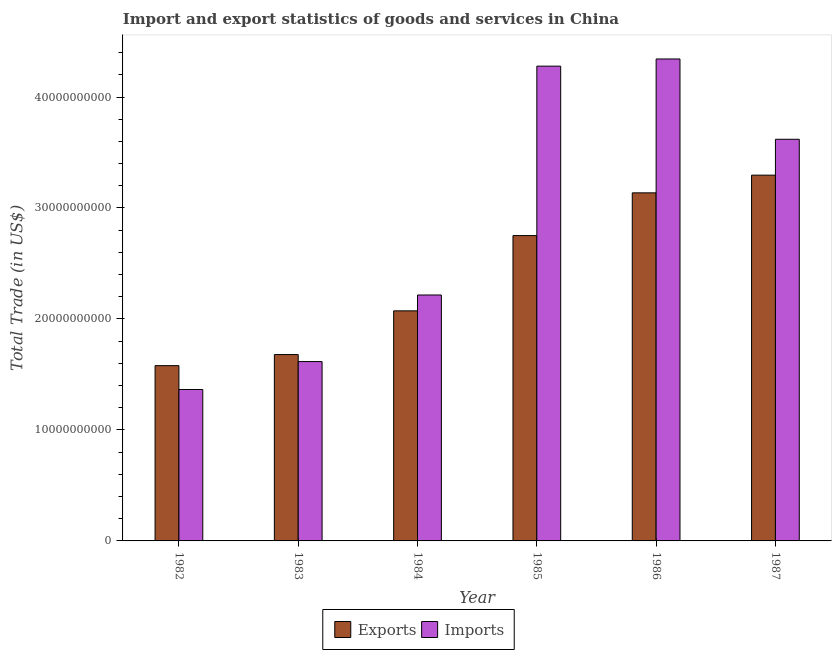What is the imports of goods and services in 1983?
Offer a terse response. 1.62e+1. Across all years, what is the maximum imports of goods and services?
Ensure brevity in your answer.  4.34e+1. Across all years, what is the minimum imports of goods and services?
Keep it short and to the point. 1.36e+1. What is the total export of goods and services in the graph?
Your answer should be compact. 1.45e+11. What is the difference between the export of goods and services in 1983 and that in 1984?
Keep it short and to the point. -3.94e+09. What is the difference between the export of goods and services in 1986 and the imports of goods and services in 1985?
Your response must be concise. 3.85e+09. What is the average export of goods and services per year?
Your response must be concise. 2.42e+1. In the year 1982, what is the difference between the export of goods and services and imports of goods and services?
Ensure brevity in your answer.  0. In how many years, is the imports of goods and services greater than 24000000000 US$?
Offer a terse response. 3. What is the ratio of the export of goods and services in 1983 to that in 1984?
Your answer should be very brief. 0.81. Is the imports of goods and services in 1983 less than that in 1984?
Your response must be concise. Yes. What is the difference between the highest and the second highest imports of goods and services?
Provide a succinct answer. 6.47e+08. What is the difference between the highest and the lowest export of goods and services?
Offer a terse response. 1.72e+1. In how many years, is the export of goods and services greater than the average export of goods and services taken over all years?
Your answer should be very brief. 3. What does the 2nd bar from the left in 1984 represents?
Your answer should be very brief. Imports. What does the 2nd bar from the right in 1983 represents?
Your answer should be compact. Exports. How many bars are there?
Provide a succinct answer. 12. Are all the bars in the graph horizontal?
Provide a short and direct response. No. Does the graph contain any zero values?
Keep it short and to the point. No. Does the graph contain grids?
Make the answer very short. No. How many legend labels are there?
Provide a succinct answer. 2. What is the title of the graph?
Provide a short and direct response. Import and export statistics of goods and services in China. Does "Nitrous oxide emissions" appear as one of the legend labels in the graph?
Your answer should be compact. No. What is the label or title of the Y-axis?
Offer a very short reply. Total Trade (in US$). What is the Total Trade (in US$) in Exports in 1982?
Your answer should be compact. 1.58e+1. What is the Total Trade (in US$) of Imports in 1982?
Ensure brevity in your answer.  1.36e+1. What is the Total Trade (in US$) of Exports in 1983?
Make the answer very short. 1.68e+1. What is the Total Trade (in US$) in Imports in 1983?
Keep it short and to the point. 1.62e+1. What is the Total Trade (in US$) in Exports in 1984?
Keep it short and to the point. 2.07e+1. What is the Total Trade (in US$) in Imports in 1984?
Ensure brevity in your answer.  2.22e+1. What is the Total Trade (in US$) in Exports in 1985?
Make the answer very short. 2.75e+1. What is the Total Trade (in US$) of Imports in 1985?
Keep it short and to the point. 4.28e+1. What is the Total Trade (in US$) in Exports in 1986?
Make the answer very short. 3.14e+1. What is the Total Trade (in US$) in Imports in 1986?
Provide a short and direct response. 4.34e+1. What is the Total Trade (in US$) of Exports in 1987?
Ensure brevity in your answer.  3.30e+1. What is the Total Trade (in US$) of Imports in 1987?
Offer a very short reply. 3.62e+1. Across all years, what is the maximum Total Trade (in US$) in Exports?
Ensure brevity in your answer.  3.30e+1. Across all years, what is the maximum Total Trade (in US$) of Imports?
Your response must be concise. 4.34e+1. Across all years, what is the minimum Total Trade (in US$) of Exports?
Ensure brevity in your answer.  1.58e+1. Across all years, what is the minimum Total Trade (in US$) in Imports?
Provide a short and direct response. 1.36e+1. What is the total Total Trade (in US$) in Exports in the graph?
Provide a succinct answer. 1.45e+11. What is the total Total Trade (in US$) in Imports in the graph?
Give a very brief answer. 1.74e+11. What is the difference between the Total Trade (in US$) in Exports in 1982 and that in 1983?
Keep it short and to the point. -9.99e+08. What is the difference between the Total Trade (in US$) of Imports in 1982 and that in 1983?
Ensure brevity in your answer.  -2.52e+09. What is the difference between the Total Trade (in US$) in Exports in 1982 and that in 1984?
Your answer should be compact. -4.94e+09. What is the difference between the Total Trade (in US$) in Imports in 1982 and that in 1984?
Your response must be concise. -8.52e+09. What is the difference between the Total Trade (in US$) in Exports in 1982 and that in 1985?
Provide a short and direct response. -1.17e+1. What is the difference between the Total Trade (in US$) of Imports in 1982 and that in 1985?
Offer a terse response. -2.91e+1. What is the difference between the Total Trade (in US$) in Exports in 1982 and that in 1986?
Provide a short and direct response. -1.56e+1. What is the difference between the Total Trade (in US$) in Imports in 1982 and that in 1986?
Offer a terse response. -2.98e+1. What is the difference between the Total Trade (in US$) in Exports in 1982 and that in 1987?
Make the answer very short. -1.72e+1. What is the difference between the Total Trade (in US$) in Imports in 1982 and that in 1987?
Provide a short and direct response. -2.25e+1. What is the difference between the Total Trade (in US$) of Exports in 1983 and that in 1984?
Make the answer very short. -3.94e+09. What is the difference between the Total Trade (in US$) in Imports in 1983 and that in 1984?
Your response must be concise. -6.00e+09. What is the difference between the Total Trade (in US$) of Exports in 1983 and that in 1985?
Offer a very short reply. -1.07e+1. What is the difference between the Total Trade (in US$) in Imports in 1983 and that in 1985?
Offer a very short reply. -2.66e+1. What is the difference between the Total Trade (in US$) of Exports in 1983 and that in 1986?
Your answer should be very brief. -1.46e+1. What is the difference between the Total Trade (in US$) in Imports in 1983 and that in 1986?
Ensure brevity in your answer.  -2.73e+1. What is the difference between the Total Trade (in US$) of Exports in 1983 and that in 1987?
Offer a terse response. -1.62e+1. What is the difference between the Total Trade (in US$) of Imports in 1983 and that in 1987?
Provide a short and direct response. -2.00e+1. What is the difference between the Total Trade (in US$) of Exports in 1984 and that in 1985?
Make the answer very short. -6.78e+09. What is the difference between the Total Trade (in US$) of Imports in 1984 and that in 1985?
Give a very brief answer. -2.06e+1. What is the difference between the Total Trade (in US$) in Exports in 1984 and that in 1986?
Offer a very short reply. -1.06e+1. What is the difference between the Total Trade (in US$) in Imports in 1984 and that in 1986?
Your answer should be compact. -2.13e+1. What is the difference between the Total Trade (in US$) of Exports in 1984 and that in 1987?
Your answer should be compact. -1.22e+1. What is the difference between the Total Trade (in US$) of Imports in 1984 and that in 1987?
Provide a succinct answer. -1.40e+1. What is the difference between the Total Trade (in US$) in Exports in 1985 and that in 1986?
Keep it short and to the point. -3.85e+09. What is the difference between the Total Trade (in US$) of Imports in 1985 and that in 1986?
Provide a short and direct response. -6.47e+08. What is the difference between the Total Trade (in US$) in Exports in 1985 and that in 1987?
Provide a succinct answer. -5.45e+09. What is the difference between the Total Trade (in US$) of Imports in 1985 and that in 1987?
Provide a succinct answer. 6.59e+09. What is the difference between the Total Trade (in US$) of Exports in 1986 and that in 1987?
Your response must be concise. -1.59e+09. What is the difference between the Total Trade (in US$) of Imports in 1986 and that in 1987?
Provide a succinct answer. 7.24e+09. What is the difference between the Total Trade (in US$) of Exports in 1982 and the Total Trade (in US$) of Imports in 1983?
Your response must be concise. -3.67e+08. What is the difference between the Total Trade (in US$) of Exports in 1982 and the Total Trade (in US$) of Imports in 1984?
Keep it short and to the point. -6.37e+09. What is the difference between the Total Trade (in US$) in Exports in 1982 and the Total Trade (in US$) in Imports in 1985?
Provide a succinct answer. -2.70e+1. What is the difference between the Total Trade (in US$) in Exports in 1982 and the Total Trade (in US$) in Imports in 1986?
Offer a terse response. -2.76e+1. What is the difference between the Total Trade (in US$) in Exports in 1982 and the Total Trade (in US$) in Imports in 1987?
Offer a very short reply. -2.04e+1. What is the difference between the Total Trade (in US$) of Exports in 1983 and the Total Trade (in US$) of Imports in 1984?
Give a very brief answer. -5.37e+09. What is the difference between the Total Trade (in US$) of Exports in 1983 and the Total Trade (in US$) of Imports in 1985?
Provide a short and direct response. -2.60e+1. What is the difference between the Total Trade (in US$) of Exports in 1983 and the Total Trade (in US$) of Imports in 1986?
Ensure brevity in your answer.  -2.66e+1. What is the difference between the Total Trade (in US$) in Exports in 1983 and the Total Trade (in US$) in Imports in 1987?
Ensure brevity in your answer.  -1.94e+1. What is the difference between the Total Trade (in US$) of Exports in 1984 and the Total Trade (in US$) of Imports in 1985?
Offer a very short reply. -2.21e+1. What is the difference between the Total Trade (in US$) of Exports in 1984 and the Total Trade (in US$) of Imports in 1986?
Your answer should be compact. -2.27e+1. What is the difference between the Total Trade (in US$) of Exports in 1984 and the Total Trade (in US$) of Imports in 1987?
Provide a succinct answer. -1.55e+1. What is the difference between the Total Trade (in US$) of Exports in 1985 and the Total Trade (in US$) of Imports in 1986?
Your answer should be very brief. -1.59e+1. What is the difference between the Total Trade (in US$) in Exports in 1985 and the Total Trade (in US$) in Imports in 1987?
Offer a terse response. -8.68e+09. What is the difference between the Total Trade (in US$) in Exports in 1986 and the Total Trade (in US$) in Imports in 1987?
Offer a terse response. -4.83e+09. What is the average Total Trade (in US$) of Exports per year?
Make the answer very short. 2.42e+1. What is the average Total Trade (in US$) in Imports per year?
Your answer should be compact. 2.91e+1. In the year 1982, what is the difference between the Total Trade (in US$) of Exports and Total Trade (in US$) of Imports?
Give a very brief answer. 2.15e+09. In the year 1983, what is the difference between the Total Trade (in US$) in Exports and Total Trade (in US$) in Imports?
Your answer should be very brief. 6.32e+08. In the year 1984, what is the difference between the Total Trade (in US$) of Exports and Total Trade (in US$) of Imports?
Your answer should be compact. -1.43e+09. In the year 1985, what is the difference between the Total Trade (in US$) of Exports and Total Trade (in US$) of Imports?
Provide a succinct answer. -1.53e+1. In the year 1986, what is the difference between the Total Trade (in US$) in Exports and Total Trade (in US$) in Imports?
Make the answer very short. -1.21e+1. In the year 1987, what is the difference between the Total Trade (in US$) in Exports and Total Trade (in US$) in Imports?
Your answer should be compact. -3.23e+09. What is the ratio of the Total Trade (in US$) of Exports in 1982 to that in 1983?
Ensure brevity in your answer.  0.94. What is the ratio of the Total Trade (in US$) of Imports in 1982 to that in 1983?
Ensure brevity in your answer.  0.84. What is the ratio of the Total Trade (in US$) in Exports in 1982 to that in 1984?
Offer a very short reply. 0.76. What is the ratio of the Total Trade (in US$) of Imports in 1982 to that in 1984?
Make the answer very short. 0.62. What is the ratio of the Total Trade (in US$) in Exports in 1982 to that in 1985?
Keep it short and to the point. 0.57. What is the ratio of the Total Trade (in US$) in Imports in 1982 to that in 1985?
Your answer should be compact. 0.32. What is the ratio of the Total Trade (in US$) of Exports in 1982 to that in 1986?
Offer a terse response. 0.5. What is the ratio of the Total Trade (in US$) in Imports in 1982 to that in 1986?
Your answer should be compact. 0.31. What is the ratio of the Total Trade (in US$) in Exports in 1982 to that in 1987?
Offer a very short reply. 0.48. What is the ratio of the Total Trade (in US$) in Imports in 1982 to that in 1987?
Your answer should be compact. 0.38. What is the ratio of the Total Trade (in US$) in Exports in 1983 to that in 1984?
Give a very brief answer. 0.81. What is the ratio of the Total Trade (in US$) in Imports in 1983 to that in 1984?
Provide a short and direct response. 0.73. What is the ratio of the Total Trade (in US$) in Exports in 1983 to that in 1985?
Provide a short and direct response. 0.61. What is the ratio of the Total Trade (in US$) in Imports in 1983 to that in 1985?
Your answer should be compact. 0.38. What is the ratio of the Total Trade (in US$) in Exports in 1983 to that in 1986?
Ensure brevity in your answer.  0.54. What is the ratio of the Total Trade (in US$) in Imports in 1983 to that in 1986?
Offer a terse response. 0.37. What is the ratio of the Total Trade (in US$) in Exports in 1983 to that in 1987?
Offer a terse response. 0.51. What is the ratio of the Total Trade (in US$) in Imports in 1983 to that in 1987?
Give a very brief answer. 0.45. What is the ratio of the Total Trade (in US$) of Exports in 1984 to that in 1985?
Make the answer very short. 0.75. What is the ratio of the Total Trade (in US$) of Imports in 1984 to that in 1985?
Give a very brief answer. 0.52. What is the ratio of the Total Trade (in US$) in Exports in 1984 to that in 1986?
Offer a very short reply. 0.66. What is the ratio of the Total Trade (in US$) in Imports in 1984 to that in 1986?
Your response must be concise. 0.51. What is the ratio of the Total Trade (in US$) in Exports in 1984 to that in 1987?
Offer a very short reply. 0.63. What is the ratio of the Total Trade (in US$) of Imports in 1984 to that in 1987?
Provide a short and direct response. 0.61. What is the ratio of the Total Trade (in US$) in Exports in 1985 to that in 1986?
Give a very brief answer. 0.88. What is the ratio of the Total Trade (in US$) of Imports in 1985 to that in 1986?
Keep it short and to the point. 0.99. What is the ratio of the Total Trade (in US$) in Exports in 1985 to that in 1987?
Make the answer very short. 0.83. What is the ratio of the Total Trade (in US$) in Imports in 1985 to that in 1987?
Offer a very short reply. 1.18. What is the ratio of the Total Trade (in US$) in Exports in 1986 to that in 1987?
Give a very brief answer. 0.95. What is the ratio of the Total Trade (in US$) in Imports in 1986 to that in 1987?
Make the answer very short. 1.2. What is the difference between the highest and the second highest Total Trade (in US$) in Exports?
Give a very brief answer. 1.59e+09. What is the difference between the highest and the second highest Total Trade (in US$) of Imports?
Make the answer very short. 6.47e+08. What is the difference between the highest and the lowest Total Trade (in US$) of Exports?
Ensure brevity in your answer.  1.72e+1. What is the difference between the highest and the lowest Total Trade (in US$) of Imports?
Make the answer very short. 2.98e+1. 